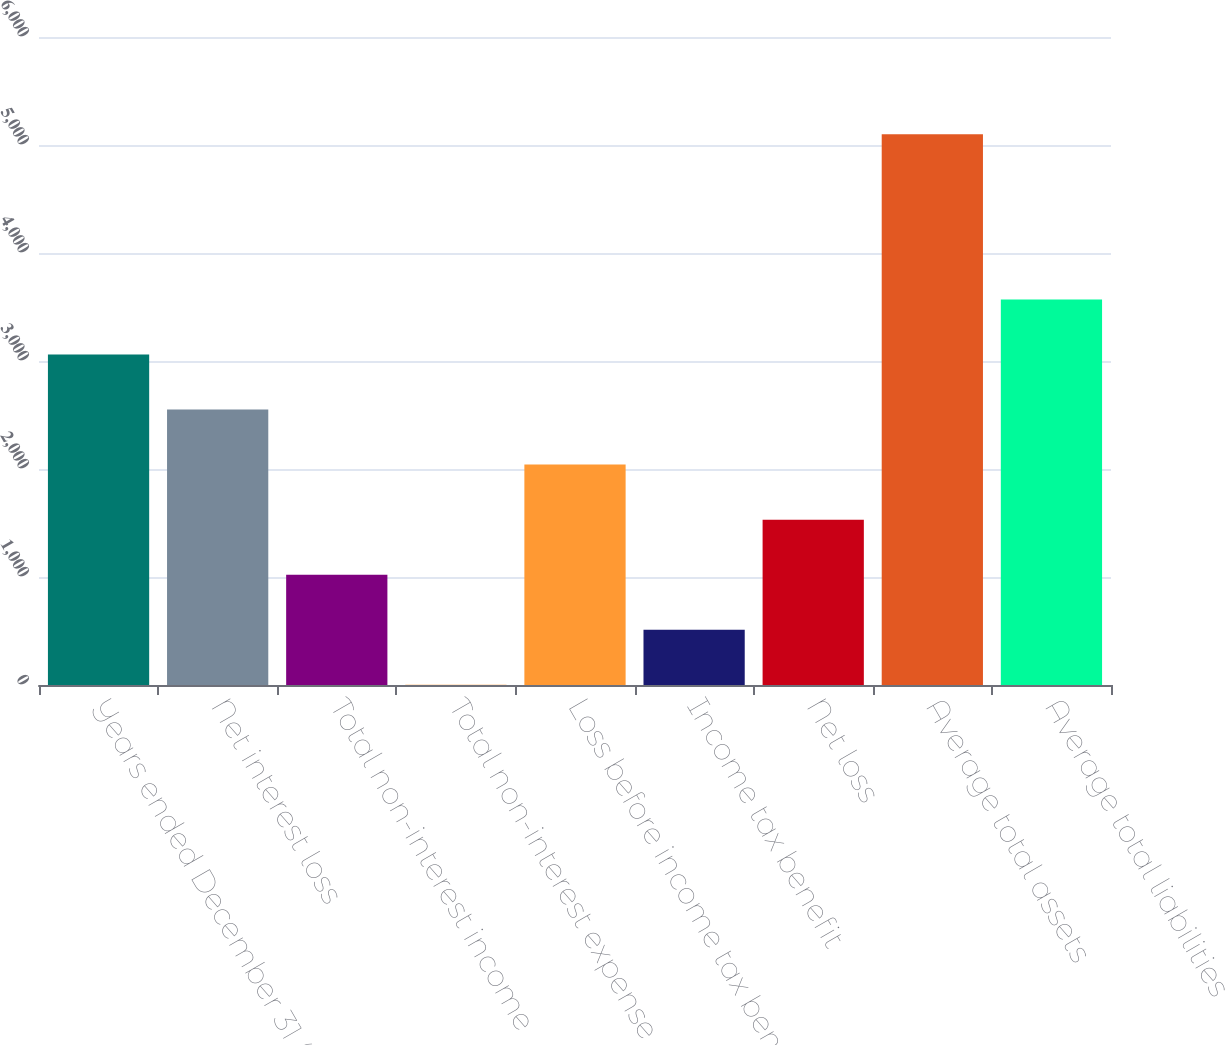Convert chart to OTSL. <chart><loc_0><loc_0><loc_500><loc_500><bar_chart><fcel>Years ended December 31 (in<fcel>Net interest loss<fcel>Total non-interest income<fcel>Total non-interest expense<fcel>Loss before income tax benefit<fcel>Income tax benefit<fcel>Net loss<fcel>Average total assets<fcel>Average total liabilities<nl><fcel>3060.18<fcel>2550.35<fcel>1020.86<fcel>1.2<fcel>2040.52<fcel>511.03<fcel>1530.69<fcel>5099.5<fcel>3570.01<nl></chart> 